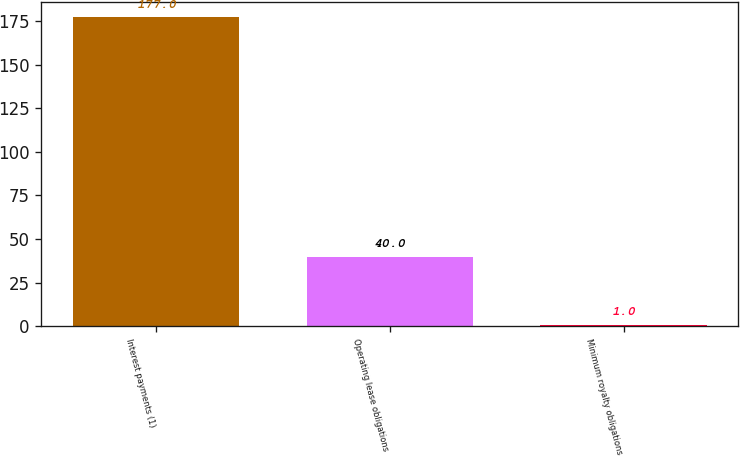Convert chart. <chart><loc_0><loc_0><loc_500><loc_500><bar_chart><fcel>Interest payments (1)<fcel>Operating lease obligations<fcel>Minimum royalty obligations<nl><fcel>177<fcel>40<fcel>1<nl></chart> 